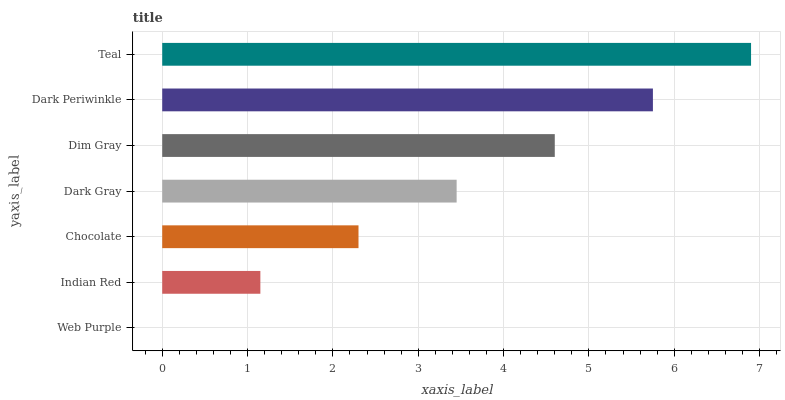Is Web Purple the minimum?
Answer yes or no. Yes. Is Teal the maximum?
Answer yes or no. Yes. Is Indian Red the minimum?
Answer yes or no. No. Is Indian Red the maximum?
Answer yes or no. No. Is Indian Red greater than Web Purple?
Answer yes or no. Yes. Is Web Purple less than Indian Red?
Answer yes or no. Yes. Is Web Purple greater than Indian Red?
Answer yes or no. No. Is Indian Red less than Web Purple?
Answer yes or no. No. Is Dark Gray the high median?
Answer yes or no. Yes. Is Dark Gray the low median?
Answer yes or no. Yes. Is Dim Gray the high median?
Answer yes or no. No. Is Dark Periwinkle the low median?
Answer yes or no. No. 